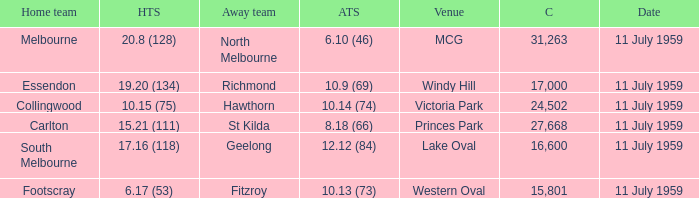How many points does footscray score as the home side? 6.17 (53). 